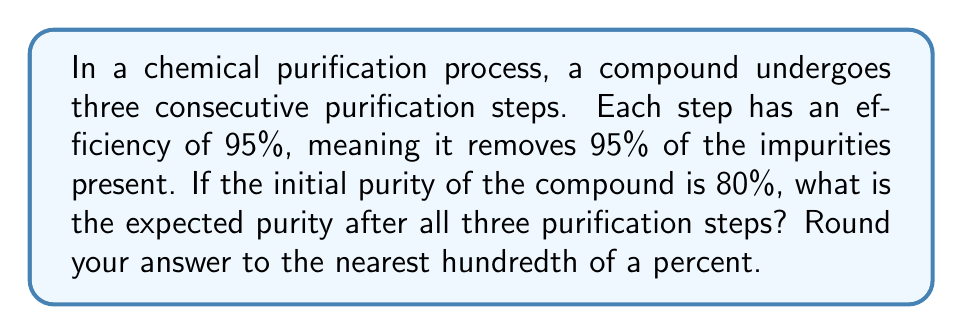Can you answer this question? Let's approach this step-by-step:

1) First, we need to understand what happens in each purification step:
   - Each step removes 95% of the impurities present
   - This means that 5% of the impurities remain after each step

2) Let's calculate the impurity after each step:
   - Initial impurity: 100% - 80% = 20%
   
   - After first step: 
     $20\% \times 5\% = 1\%$ impurity remains
     Purity after first step: $100\% - 1\% = 99\%$

   - After second step:
     $1\% \times 5\% = 0.05\%$ impurity remains
     Purity after second step: $100\% - 0.05\% = 99.95\%$

   - After third step:
     $0.05\% \times 5\% = 0.0025\%$ impurity remains
     Purity after third step: $100\% - 0.0025\% = 99.9975\%$

3) Rounding to the nearest hundredth of a percent:
   99.9975% rounds to 100.00%

Therefore, the expected purity after all three purification steps is 100.00%.
Answer: 100.00% 